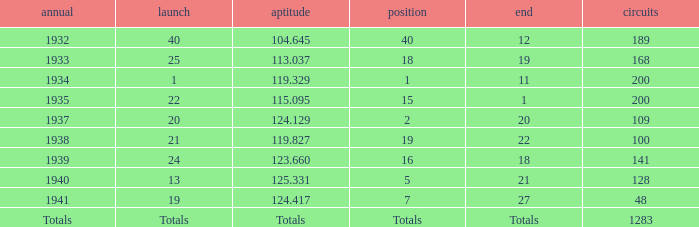What was the finish place with a qual of 123.660? 18.0. 